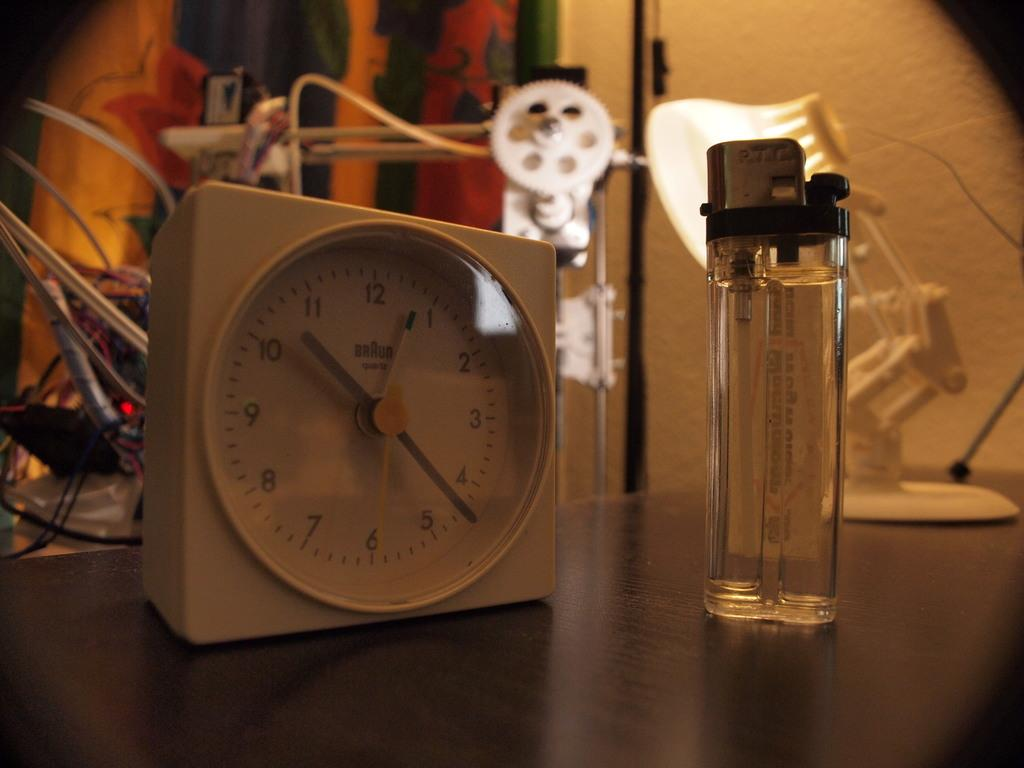<image>
Write a terse but informative summary of the picture. the clock beside the lighter says that it is 10:23 